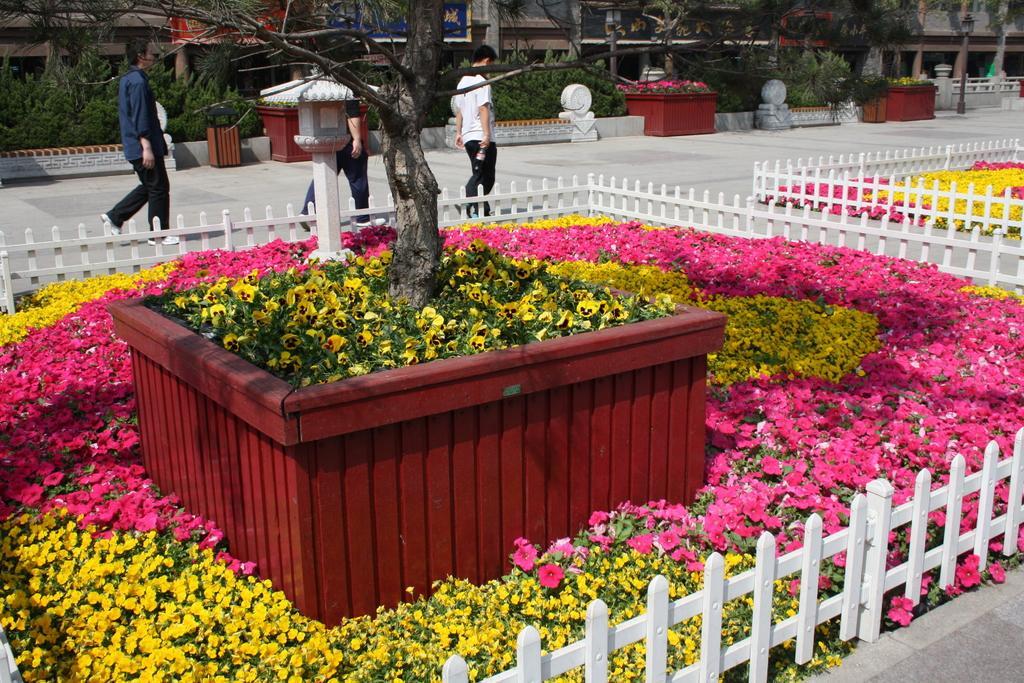How would you summarize this image in a sentence or two? In this image there is a flower garden in the middle which is surrounded by the wooden fence. There are yellow and pink flowers all over the place. In the background there is a road on which there are few people walking on it. In the background there is a building. In the middle there is a tree. Under the tree there are yellow flowers. 